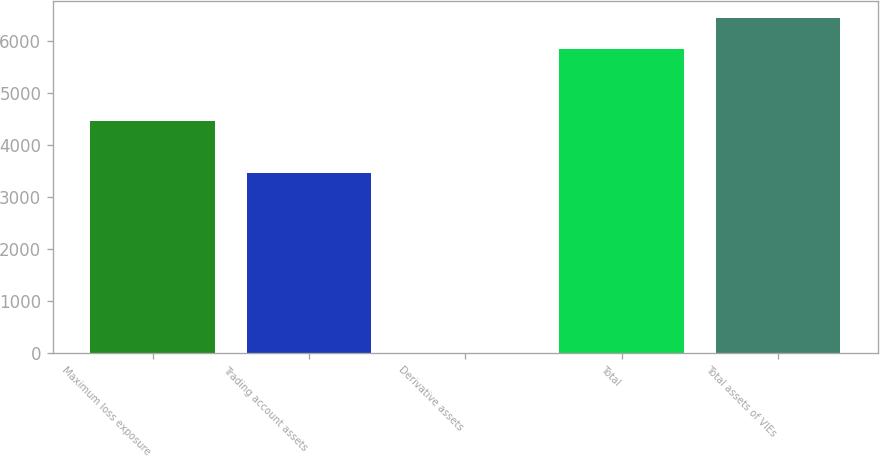Convert chart. <chart><loc_0><loc_0><loc_500><loc_500><bar_chart><fcel>Maximum loss exposure<fcel>Trading account assets<fcel>Derivative assets<fcel>Total<fcel>Total assets of VIEs<nl><fcel>4449<fcel>3458<fcel>1<fcel>5847<fcel>6431.6<nl></chart> 